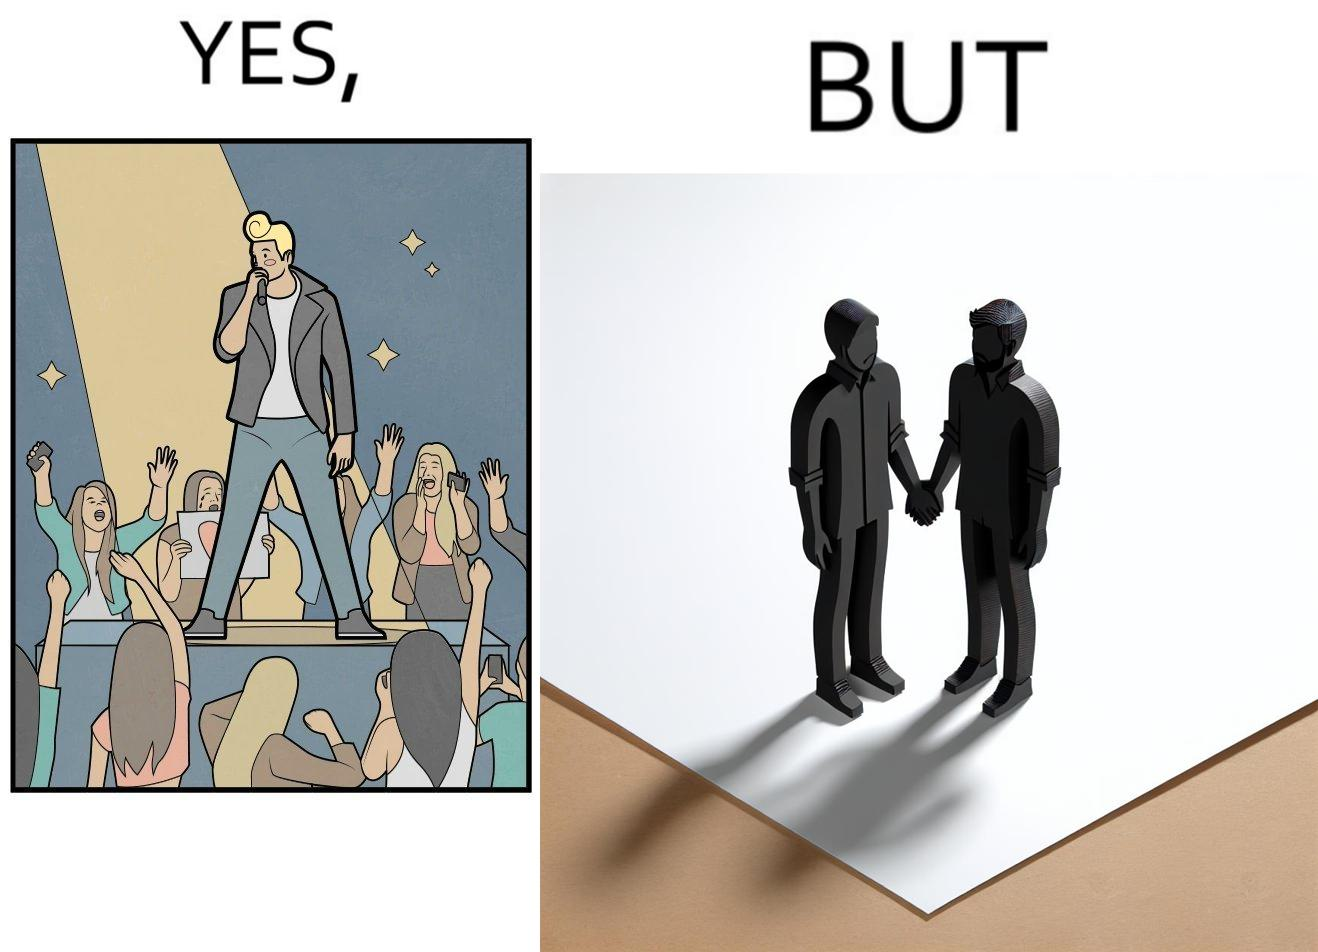What makes this image funny or satirical? The image is funny because while the girls loves the man, he likes other men instead of women. 